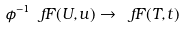<formula> <loc_0><loc_0><loc_500><loc_500>\phi ^ { - 1 } \ f F ( U , u ) \to \ f F ( T , t )</formula> 